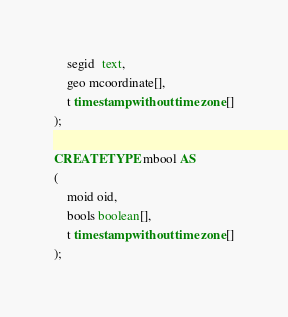Convert code to text. <code><loc_0><loc_0><loc_500><loc_500><_SQL_>	segid  text,
	geo mcoordinate[],
	t timestamp without time zone[]
);

CREATE TYPE mbool AS
(
	moid oid,
	bools boolean[],
	t timestamp without time zone[]
);


</code> 